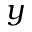Convert formula to latex. <formula><loc_0><loc_0><loc_500><loc_500>y</formula> 